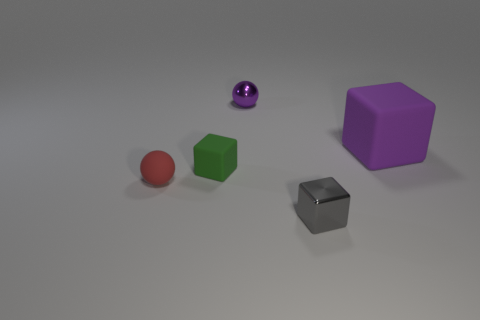Subtract all gray blocks. How many blocks are left? 2 Add 1 tiny gray shiny balls. How many objects exist? 6 Subtract all balls. How many objects are left? 3 Subtract 2 cubes. How many cubes are left? 1 Subtract all purple blocks. How many blocks are left? 2 Add 5 tiny green things. How many tiny green things are left? 6 Add 2 large yellow rubber balls. How many large yellow rubber balls exist? 2 Subtract 0 yellow balls. How many objects are left? 5 Subtract all gray spheres. Subtract all gray cylinders. How many spheres are left? 2 Subtract all yellow blocks. How many red balls are left? 1 